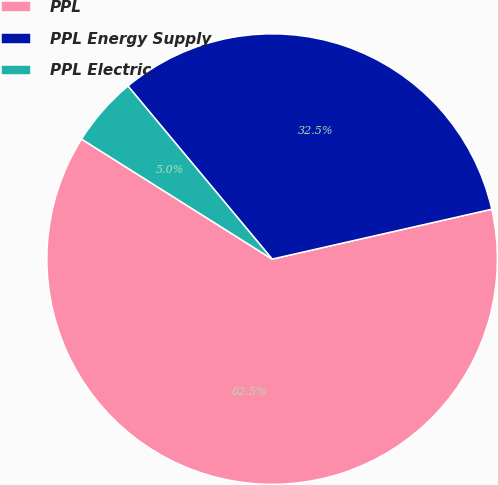<chart> <loc_0><loc_0><loc_500><loc_500><pie_chart><fcel>PPL<fcel>PPL Energy Supply<fcel>PPL Electric<nl><fcel>62.5%<fcel>32.5%<fcel>5.0%<nl></chart> 